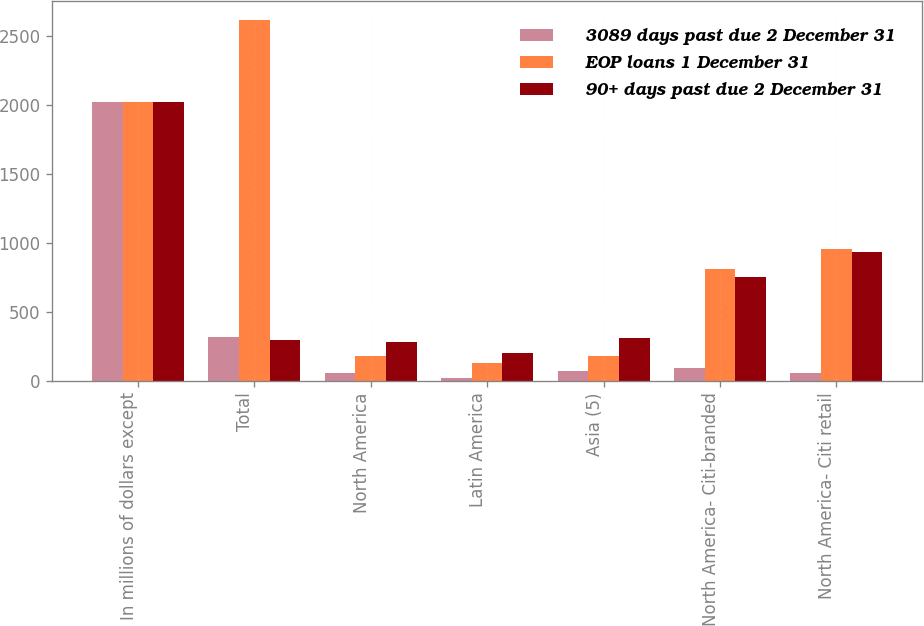<chart> <loc_0><loc_0><loc_500><loc_500><stacked_bar_chart><ecel><fcel>In millions of dollars except<fcel>Total<fcel>North America<fcel>Latin America<fcel>Asia (5)<fcel>North America- Citi-branded<fcel>North America- Citi retail<nl><fcel>3089 days past due 2 December 31<fcel>2018<fcel>315.2<fcel>56.8<fcel>19.7<fcel>69.2<fcel>91.8<fcel>52.7<nl><fcel>EOP loans 1 December 31<fcel>2018<fcel>2619<fcel>180<fcel>127<fcel>178<fcel>812<fcel>952<nl><fcel>90+ days past due 2 December 31<fcel>2018<fcel>294.5<fcel>282<fcel>201<fcel>307<fcel>755<fcel>932<nl></chart> 